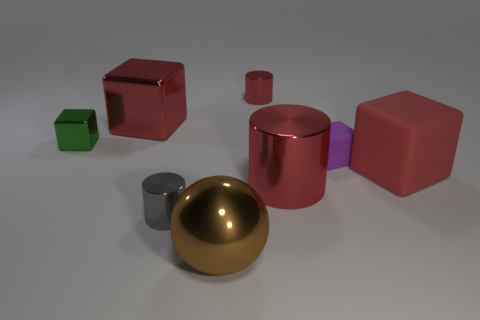The large matte object has what color?
Your answer should be very brief. Red. There is a cylinder in front of the big cylinder; are there any big red objects that are to the right of it?
Ensure brevity in your answer.  Yes. What shape is the tiny shiny object in front of the matte thing that is on the right side of the small matte object?
Give a very brief answer. Cylinder. Is the number of big gray matte cylinders less than the number of tiny gray cylinders?
Offer a very short reply. Yes. Is the material of the small green block the same as the big brown sphere?
Make the answer very short. Yes. The shiny thing that is behind the small green shiny thing and on the right side of the tiny gray thing is what color?
Offer a terse response. Red. Is there a cylinder that has the same size as the brown object?
Offer a terse response. Yes. What size is the red cylinder in front of the large block that is on the left side of the red matte thing?
Make the answer very short. Large. Is the number of tiny purple rubber things in front of the gray shiny thing less than the number of purple rubber objects?
Keep it short and to the point. Yes. Is the small metallic cube the same color as the tiny rubber cube?
Your response must be concise. No. 